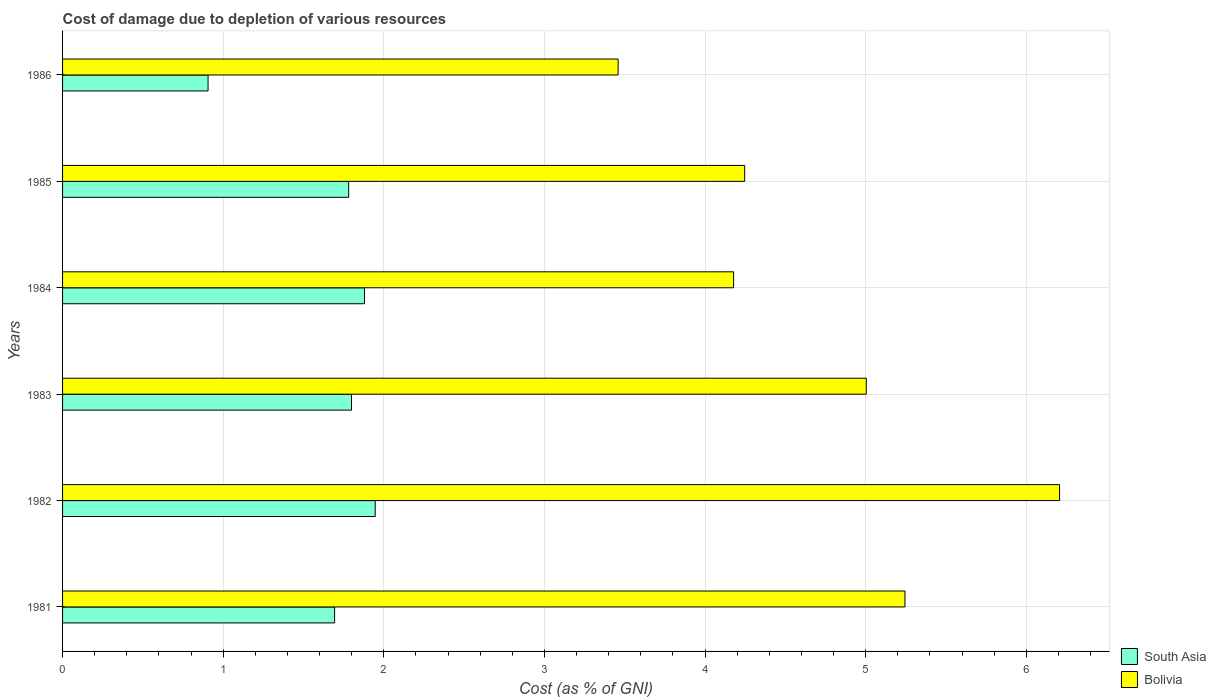How many bars are there on the 5th tick from the top?
Give a very brief answer. 2. What is the label of the 5th group of bars from the top?
Your answer should be very brief. 1982. In how many cases, is the number of bars for a given year not equal to the number of legend labels?
Give a very brief answer. 0. What is the cost of damage caused due to the depletion of various resources in South Asia in 1983?
Make the answer very short. 1.8. Across all years, what is the maximum cost of damage caused due to the depletion of various resources in South Asia?
Your response must be concise. 1.95. Across all years, what is the minimum cost of damage caused due to the depletion of various resources in South Asia?
Provide a succinct answer. 0.91. What is the total cost of damage caused due to the depletion of various resources in South Asia in the graph?
Your answer should be compact. 10.01. What is the difference between the cost of damage caused due to the depletion of various resources in South Asia in 1981 and that in 1983?
Ensure brevity in your answer.  -0.11. What is the difference between the cost of damage caused due to the depletion of various resources in South Asia in 1985 and the cost of damage caused due to the depletion of various resources in Bolivia in 1986?
Provide a succinct answer. -1.68. What is the average cost of damage caused due to the depletion of various resources in Bolivia per year?
Your response must be concise. 4.72. In the year 1986, what is the difference between the cost of damage caused due to the depletion of various resources in South Asia and cost of damage caused due to the depletion of various resources in Bolivia?
Keep it short and to the point. -2.55. What is the ratio of the cost of damage caused due to the depletion of various resources in Bolivia in 1984 to that in 1986?
Keep it short and to the point. 1.21. Is the cost of damage caused due to the depletion of various resources in South Asia in 1984 less than that in 1985?
Provide a short and direct response. No. Is the difference between the cost of damage caused due to the depletion of various resources in South Asia in 1982 and 1985 greater than the difference between the cost of damage caused due to the depletion of various resources in Bolivia in 1982 and 1985?
Offer a terse response. No. What is the difference between the highest and the second highest cost of damage caused due to the depletion of various resources in Bolivia?
Your response must be concise. 0.96. What is the difference between the highest and the lowest cost of damage caused due to the depletion of various resources in South Asia?
Keep it short and to the point. 1.04. In how many years, is the cost of damage caused due to the depletion of various resources in South Asia greater than the average cost of damage caused due to the depletion of various resources in South Asia taken over all years?
Ensure brevity in your answer.  5. Is the sum of the cost of damage caused due to the depletion of various resources in South Asia in 1983 and 1984 greater than the maximum cost of damage caused due to the depletion of various resources in Bolivia across all years?
Provide a short and direct response. No. How many bars are there?
Offer a very short reply. 12. How many years are there in the graph?
Offer a very short reply. 6. What is the difference between two consecutive major ticks on the X-axis?
Keep it short and to the point. 1. Does the graph contain any zero values?
Make the answer very short. No. Does the graph contain grids?
Keep it short and to the point. Yes. Where does the legend appear in the graph?
Ensure brevity in your answer.  Bottom right. How many legend labels are there?
Offer a very short reply. 2. What is the title of the graph?
Your response must be concise. Cost of damage due to depletion of various resources. What is the label or title of the X-axis?
Offer a terse response. Cost (as % of GNI). What is the Cost (as % of GNI) of South Asia in 1981?
Ensure brevity in your answer.  1.69. What is the Cost (as % of GNI) of Bolivia in 1981?
Make the answer very short. 5.24. What is the Cost (as % of GNI) of South Asia in 1982?
Keep it short and to the point. 1.95. What is the Cost (as % of GNI) of Bolivia in 1982?
Provide a short and direct response. 6.21. What is the Cost (as % of GNI) in South Asia in 1983?
Give a very brief answer. 1.8. What is the Cost (as % of GNI) of Bolivia in 1983?
Provide a short and direct response. 5. What is the Cost (as % of GNI) in South Asia in 1984?
Give a very brief answer. 1.88. What is the Cost (as % of GNI) in Bolivia in 1984?
Your answer should be very brief. 4.18. What is the Cost (as % of GNI) in South Asia in 1985?
Make the answer very short. 1.78. What is the Cost (as % of GNI) of Bolivia in 1985?
Make the answer very short. 4.25. What is the Cost (as % of GNI) of South Asia in 1986?
Your response must be concise. 0.91. What is the Cost (as % of GNI) in Bolivia in 1986?
Your answer should be very brief. 3.46. Across all years, what is the maximum Cost (as % of GNI) in South Asia?
Your answer should be very brief. 1.95. Across all years, what is the maximum Cost (as % of GNI) in Bolivia?
Give a very brief answer. 6.21. Across all years, what is the minimum Cost (as % of GNI) of South Asia?
Your response must be concise. 0.91. Across all years, what is the minimum Cost (as % of GNI) in Bolivia?
Your answer should be very brief. 3.46. What is the total Cost (as % of GNI) of South Asia in the graph?
Keep it short and to the point. 10.01. What is the total Cost (as % of GNI) of Bolivia in the graph?
Your response must be concise. 28.34. What is the difference between the Cost (as % of GNI) of South Asia in 1981 and that in 1982?
Give a very brief answer. -0.25. What is the difference between the Cost (as % of GNI) of Bolivia in 1981 and that in 1982?
Your answer should be very brief. -0.96. What is the difference between the Cost (as % of GNI) of South Asia in 1981 and that in 1983?
Provide a succinct answer. -0.11. What is the difference between the Cost (as % of GNI) in Bolivia in 1981 and that in 1983?
Your response must be concise. 0.24. What is the difference between the Cost (as % of GNI) of South Asia in 1981 and that in 1984?
Your answer should be compact. -0.19. What is the difference between the Cost (as % of GNI) in Bolivia in 1981 and that in 1984?
Provide a short and direct response. 1.07. What is the difference between the Cost (as % of GNI) in South Asia in 1981 and that in 1985?
Ensure brevity in your answer.  -0.09. What is the difference between the Cost (as % of GNI) in Bolivia in 1981 and that in 1985?
Provide a short and direct response. 1. What is the difference between the Cost (as % of GNI) of South Asia in 1981 and that in 1986?
Ensure brevity in your answer.  0.79. What is the difference between the Cost (as % of GNI) of Bolivia in 1981 and that in 1986?
Your answer should be very brief. 1.79. What is the difference between the Cost (as % of GNI) in South Asia in 1982 and that in 1983?
Ensure brevity in your answer.  0.15. What is the difference between the Cost (as % of GNI) of Bolivia in 1982 and that in 1983?
Give a very brief answer. 1.2. What is the difference between the Cost (as % of GNI) of South Asia in 1982 and that in 1984?
Provide a short and direct response. 0.07. What is the difference between the Cost (as % of GNI) of Bolivia in 1982 and that in 1984?
Keep it short and to the point. 2.03. What is the difference between the Cost (as % of GNI) of South Asia in 1982 and that in 1985?
Provide a succinct answer. 0.17. What is the difference between the Cost (as % of GNI) of Bolivia in 1982 and that in 1985?
Provide a short and direct response. 1.96. What is the difference between the Cost (as % of GNI) in South Asia in 1982 and that in 1986?
Offer a very short reply. 1.04. What is the difference between the Cost (as % of GNI) in Bolivia in 1982 and that in 1986?
Ensure brevity in your answer.  2.75. What is the difference between the Cost (as % of GNI) of South Asia in 1983 and that in 1984?
Your response must be concise. -0.08. What is the difference between the Cost (as % of GNI) in Bolivia in 1983 and that in 1984?
Make the answer very short. 0.83. What is the difference between the Cost (as % of GNI) of South Asia in 1983 and that in 1985?
Provide a succinct answer. 0.02. What is the difference between the Cost (as % of GNI) in Bolivia in 1983 and that in 1985?
Make the answer very short. 0.76. What is the difference between the Cost (as % of GNI) in South Asia in 1983 and that in 1986?
Provide a succinct answer. 0.89. What is the difference between the Cost (as % of GNI) in Bolivia in 1983 and that in 1986?
Ensure brevity in your answer.  1.54. What is the difference between the Cost (as % of GNI) in South Asia in 1984 and that in 1985?
Your response must be concise. 0.1. What is the difference between the Cost (as % of GNI) in Bolivia in 1984 and that in 1985?
Offer a terse response. -0.07. What is the difference between the Cost (as % of GNI) of South Asia in 1984 and that in 1986?
Provide a succinct answer. 0.97. What is the difference between the Cost (as % of GNI) in Bolivia in 1984 and that in 1986?
Your answer should be very brief. 0.72. What is the difference between the Cost (as % of GNI) in South Asia in 1985 and that in 1986?
Offer a terse response. 0.88. What is the difference between the Cost (as % of GNI) in Bolivia in 1985 and that in 1986?
Ensure brevity in your answer.  0.79. What is the difference between the Cost (as % of GNI) in South Asia in 1981 and the Cost (as % of GNI) in Bolivia in 1982?
Ensure brevity in your answer.  -4.51. What is the difference between the Cost (as % of GNI) in South Asia in 1981 and the Cost (as % of GNI) in Bolivia in 1983?
Your answer should be very brief. -3.31. What is the difference between the Cost (as % of GNI) in South Asia in 1981 and the Cost (as % of GNI) in Bolivia in 1984?
Keep it short and to the point. -2.48. What is the difference between the Cost (as % of GNI) of South Asia in 1981 and the Cost (as % of GNI) of Bolivia in 1985?
Offer a very short reply. -2.55. What is the difference between the Cost (as % of GNI) in South Asia in 1981 and the Cost (as % of GNI) in Bolivia in 1986?
Offer a terse response. -1.77. What is the difference between the Cost (as % of GNI) of South Asia in 1982 and the Cost (as % of GNI) of Bolivia in 1983?
Make the answer very short. -3.06. What is the difference between the Cost (as % of GNI) of South Asia in 1982 and the Cost (as % of GNI) of Bolivia in 1984?
Make the answer very short. -2.23. What is the difference between the Cost (as % of GNI) in South Asia in 1982 and the Cost (as % of GNI) in Bolivia in 1985?
Your answer should be very brief. -2.3. What is the difference between the Cost (as % of GNI) of South Asia in 1982 and the Cost (as % of GNI) of Bolivia in 1986?
Provide a succinct answer. -1.51. What is the difference between the Cost (as % of GNI) of South Asia in 1983 and the Cost (as % of GNI) of Bolivia in 1984?
Your response must be concise. -2.38. What is the difference between the Cost (as % of GNI) in South Asia in 1983 and the Cost (as % of GNI) in Bolivia in 1985?
Offer a terse response. -2.45. What is the difference between the Cost (as % of GNI) in South Asia in 1983 and the Cost (as % of GNI) in Bolivia in 1986?
Offer a terse response. -1.66. What is the difference between the Cost (as % of GNI) of South Asia in 1984 and the Cost (as % of GNI) of Bolivia in 1985?
Your answer should be compact. -2.37. What is the difference between the Cost (as % of GNI) in South Asia in 1984 and the Cost (as % of GNI) in Bolivia in 1986?
Provide a succinct answer. -1.58. What is the difference between the Cost (as % of GNI) in South Asia in 1985 and the Cost (as % of GNI) in Bolivia in 1986?
Offer a terse response. -1.68. What is the average Cost (as % of GNI) in South Asia per year?
Ensure brevity in your answer.  1.67. What is the average Cost (as % of GNI) of Bolivia per year?
Your answer should be compact. 4.72. In the year 1981, what is the difference between the Cost (as % of GNI) in South Asia and Cost (as % of GNI) in Bolivia?
Your answer should be compact. -3.55. In the year 1982, what is the difference between the Cost (as % of GNI) in South Asia and Cost (as % of GNI) in Bolivia?
Your answer should be compact. -4.26. In the year 1983, what is the difference between the Cost (as % of GNI) in South Asia and Cost (as % of GNI) in Bolivia?
Offer a very short reply. -3.2. In the year 1984, what is the difference between the Cost (as % of GNI) of South Asia and Cost (as % of GNI) of Bolivia?
Provide a succinct answer. -2.3. In the year 1985, what is the difference between the Cost (as % of GNI) of South Asia and Cost (as % of GNI) of Bolivia?
Your answer should be compact. -2.47. In the year 1986, what is the difference between the Cost (as % of GNI) of South Asia and Cost (as % of GNI) of Bolivia?
Make the answer very short. -2.55. What is the ratio of the Cost (as % of GNI) in South Asia in 1981 to that in 1982?
Offer a terse response. 0.87. What is the ratio of the Cost (as % of GNI) of Bolivia in 1981 to that in 1982?
Ensure brevity in your answer.  0.84. What is the ratio of the Cost (as % of GNI) of South Asia in 1981 to that in 1983?
Offer a terse response. 0.94. What is the ratio of the Cost (as % of GNI) in Bolivia in 1981 to that in 1983?
Your response must be concise. 1.05. What is the ratio of the Cost (as % of GNI) of South Asia in 1981 to that in 1984?
Make the answer very short. 0.9. What is the ratio of the Cost (as % of GNI) of Bolivia in 1981 to that in 1984?
Your answer should be very brief. 1.26. What is the ratio of the Cost (as % of GNI) in South Asia in 1981 to that in 1985?
Your answer should be compact. 0.95. What is the ratio of the Cost (as % of GNI) in Bolivia in 1981 to that in 1985?
Your answer should be compact. 1.24. What is the ratio of the Cost (as % of GNI) in South Asia in 1981 to that in 1986?
Keep it short and to the point. 1.87. What is the ratio of the Cost (as % of GNI) in Bolivia in 1981 to that in 1986?
Your answer should be compact. 1.52. What is the ratio of the Cost (as % of GNI) in South Asia in 1982 to that in 1983?
Your answer should be very brief. 1.08. What is the ratio of the Cost (as % of GNI) of Bolivia in 1982 to that in 1983?
Offer a terse response. 1.24. What is the ratio of the Cost (as % of GNI) of South Asia in 1982 to that in 1984?
Your response must be concise. 1.04. What is the ratio of the Cost (as % of GNI) in Bolivia in 1982 to that in 1984?
Keep it short and to the point. 1.49. What is the ratio of the Cost (as % of GNI) in South Asia in 1982 to that in 1985?
Your answer should be very brief. 1.09. What is the ratio of the Cost (as % of GNI) in Bolivia in 1982 to that in 1985?
Offer a terse response. 1.46. What is the ratio of the Cost (as % of GNI) in South Asia in 1982 to that in 1986?
Ensure brevity in your answer.  2.15. What is the ratio of the Cost (as % of GNI) in Bolivia in 1982 to that in 1986?
Your response must be concise. 1.79. What is the ratio of the Cost (as % of GNI) in Bolivia in 1983 to that in 1984?
Offer a terse response. 1.2. What is the ratio of the Cost (as % of GNI) of South Asia in 1983 to that in 1985?
Give a very brief answer. 1.01. What is the ratio of the Cost (as % of GNI) of Bolivia in 1983 to that in 1985?
Make the answer very short. 1.18. What is the ratio of the Cost (as % of GNI) of South Asia in 1983 to that in 1986?
Keep it short and to the point. 1.99. What is the ratio of the Cost (as % of GNI) of Bolivia in 1983 to that in 1986?
Offer a very short reply. 1.45. What is the ratio of the Cost (as % of GNI) in South Asia in 1984 to that in 1985?
Your response must be concise. 1.06. What is the ratio of the Cost (as % of GNI) of Bolivia in 1984 to that in 1985?
Offer a very short reply. 0.98. What is the ratio of the Cost (as % of GNI) in South Asia in 1984 to that in 1986?
Provide a short and direct response. 2.08. What is the ratio of the Cost (as % of GNI) of Bolivia in 1984 to that in 1986?
Give a very brief answer. 1.21. What is the ratio of the Cost (as % of GNI) in South Asia in 1985 to that in 1986?
Keep it short and to the point. 1.97. What is the ratio of the Cost (as % of GNI) of Bolivia in 1985 to that in 1986?
Offer a very short reply. 1.23. What is the difference between the highest and the second highest Cost (as % of GNI) in South Asia?
Provide a succinct answer. 0.07. What is the difference between the highest and the second highest Cost (as % of GNI) in Bolivia?
Ensure brevity in your answer.  0.96. What is the difference between the highest and the lowest Cost (as % of GNI) of South Asia?
Provide a short and direct response. 1.04. What is the difference between the highest and the lowest Cost (as % of GNI) in Bolivia?
Offer a terse response. 2.75. 